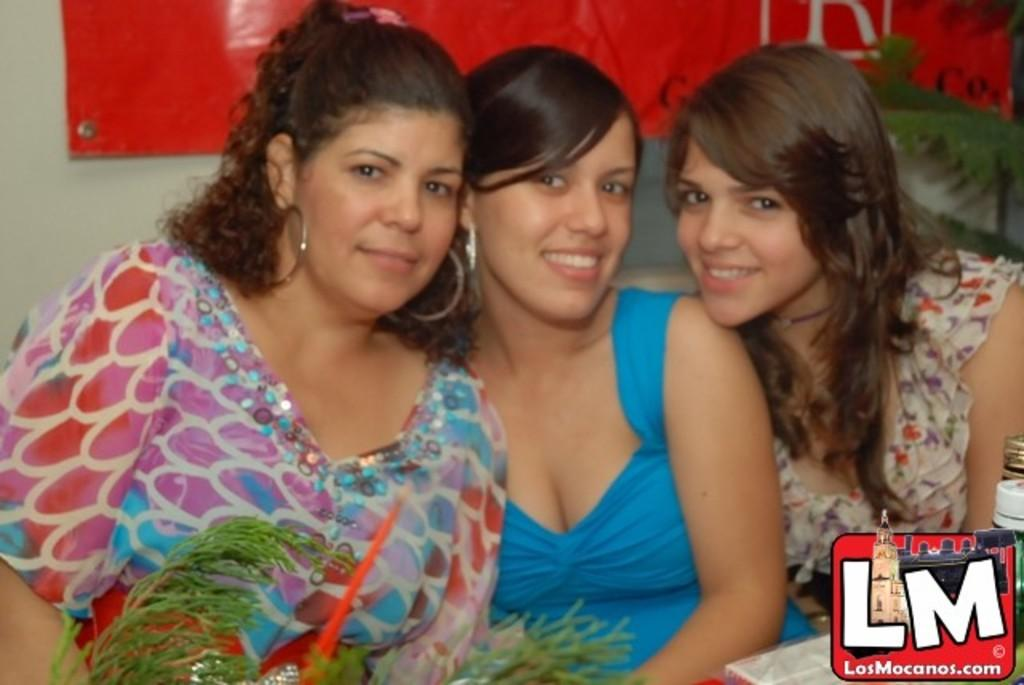How many women are present in the image? There are three women in the image. What is the facial expression of the women? All the women are smiling. Is there any text or logo visible in the image? Yes, there is a watermark in the bottom right side of the image. What can be seen in the background of the image? There is a wall visible in the background of the image. What type of eggnog is being served to the women in the image? There is no eggnog present in the image; it features three women who are smiling. Can you see any blades or sharp objects in the image? No, there are no blades or sharp objects visible in the image. 